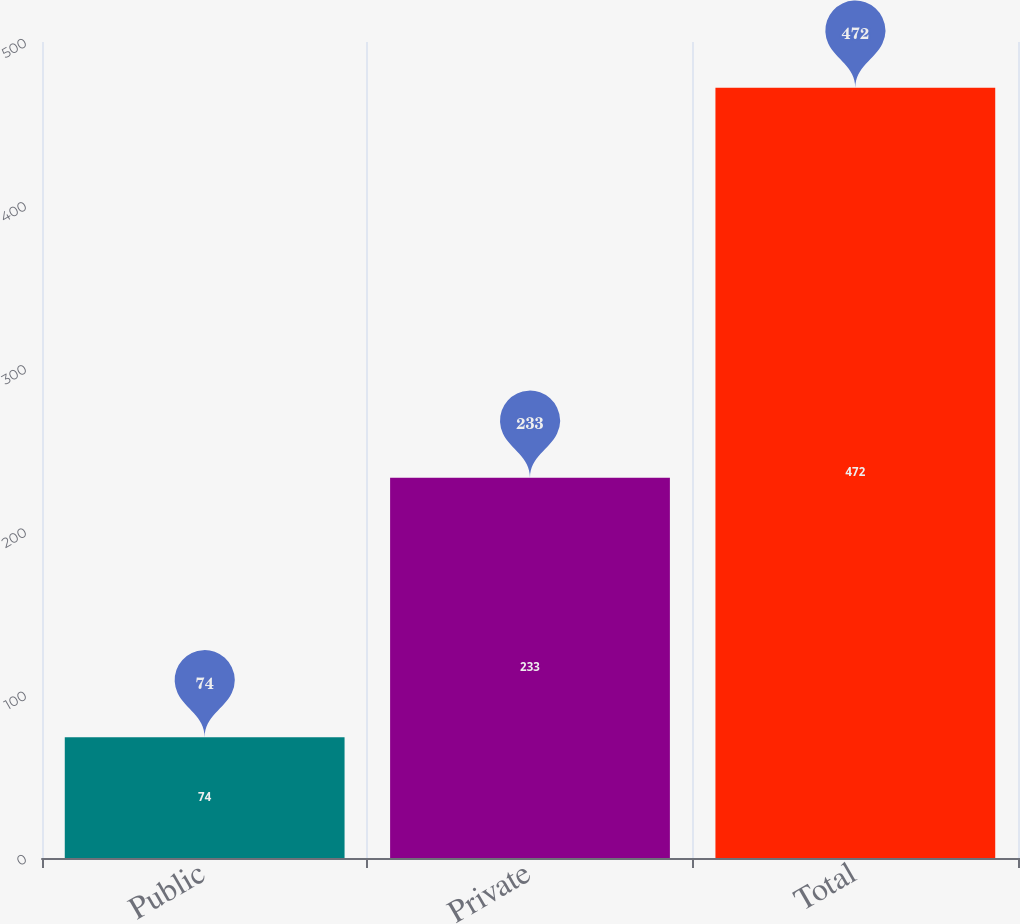Convert chart. <chart><loc_0><loc_0><loc_500><loc_500><bar_chart><fcel>Public<fcel>Private<fcel>Total<nl><fcel>74<fcel>233<fcel>472<nl></chart> 